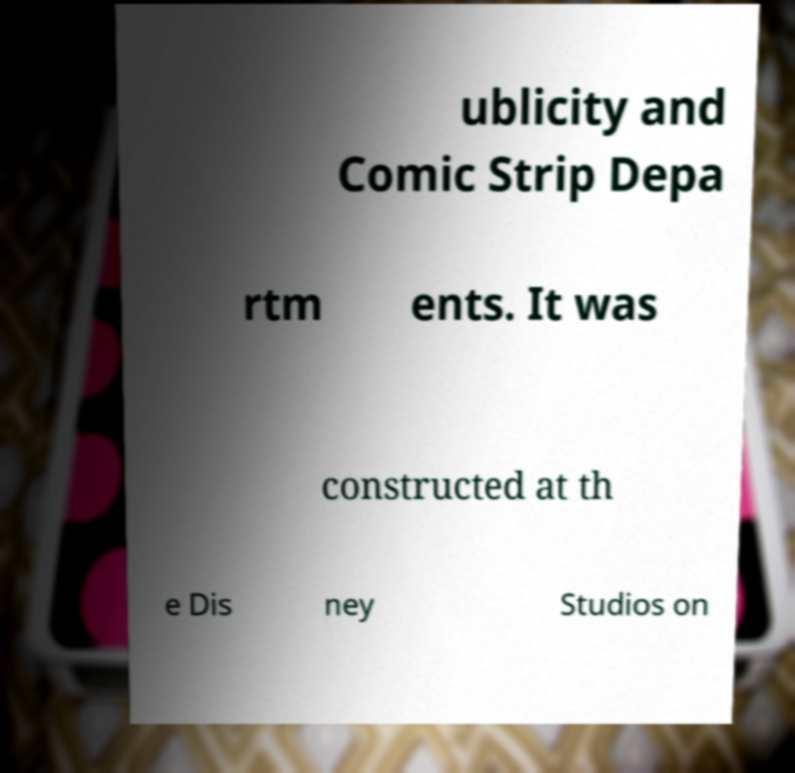Please identify and transcribe the text found in this image. ublicity and Comic Strip Depa rtm ents. It was constructed at th e Dis ney Studios on 